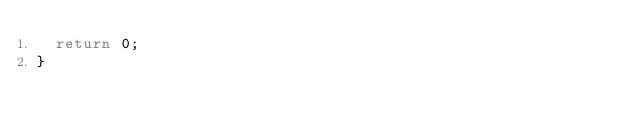<code> <loc_0><loc_0><loc_500><loc_500><_C++_>  return 0;
}
</code> 